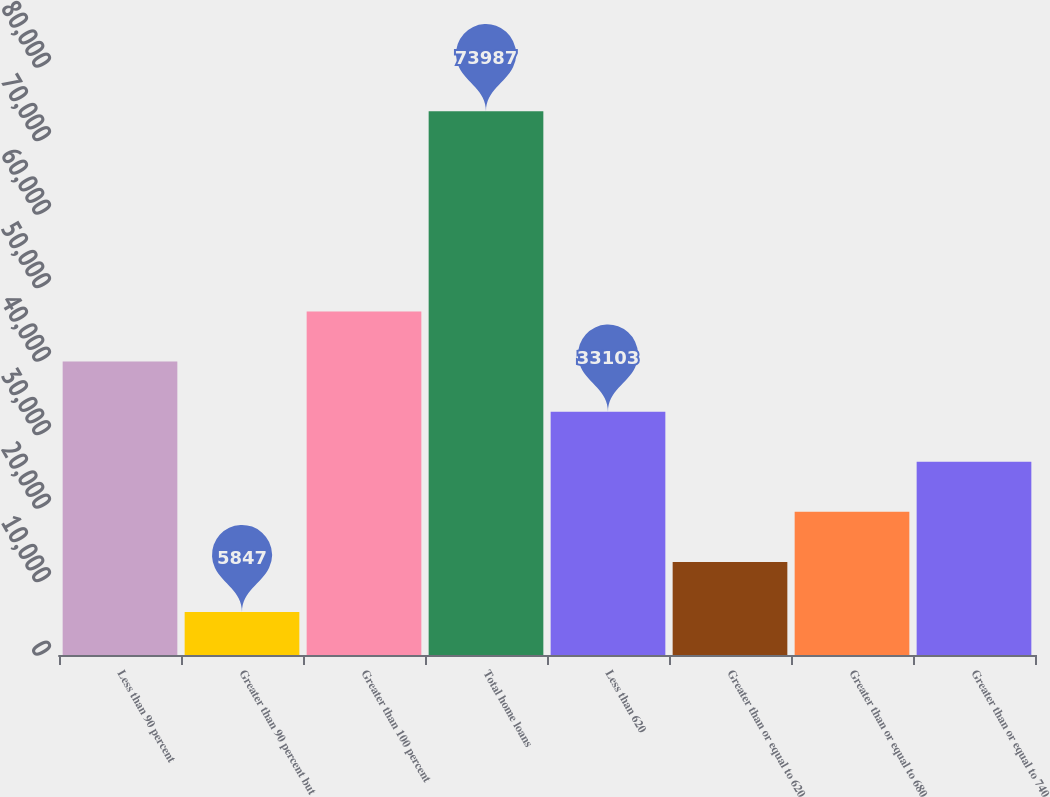Convert chart. <chart><loc_0><loc_0><loc_500><loc_500><bar_chart><fcel>Less than 90 percent<fcel>Greater than 90 percent but<fcel>Greater than 100 percent<fcel>Total home loans<fcel>Less than 620<fcel>Greater than or equal to 620<fcel>Greater than or equal to 680<fcel>Greater than or equal to 740<nl><fcel>39917<fcel>5847<fcel>46731<fcel>73987<fcel>33103<fcel>12661<fcel>19475<fcel>26289<nl></chart> 